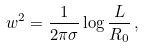Convert formula to latex. <formula><loc_0><loc_0><loc_500><loc_500>w ^ { 2 } = \frac { 1 } { 2 \pi \sigma } \log \frac { L } { R _ { 0 } } \, ,</formula> 